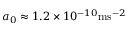Convert formula to latex. <formula><loc_0><loc_0><loc_500><loc_500>\, a _ { 0 } \approx 1 . 2 \times 1 0 ^ { - 1 0 } m s ^ { - 2 }</formula> 